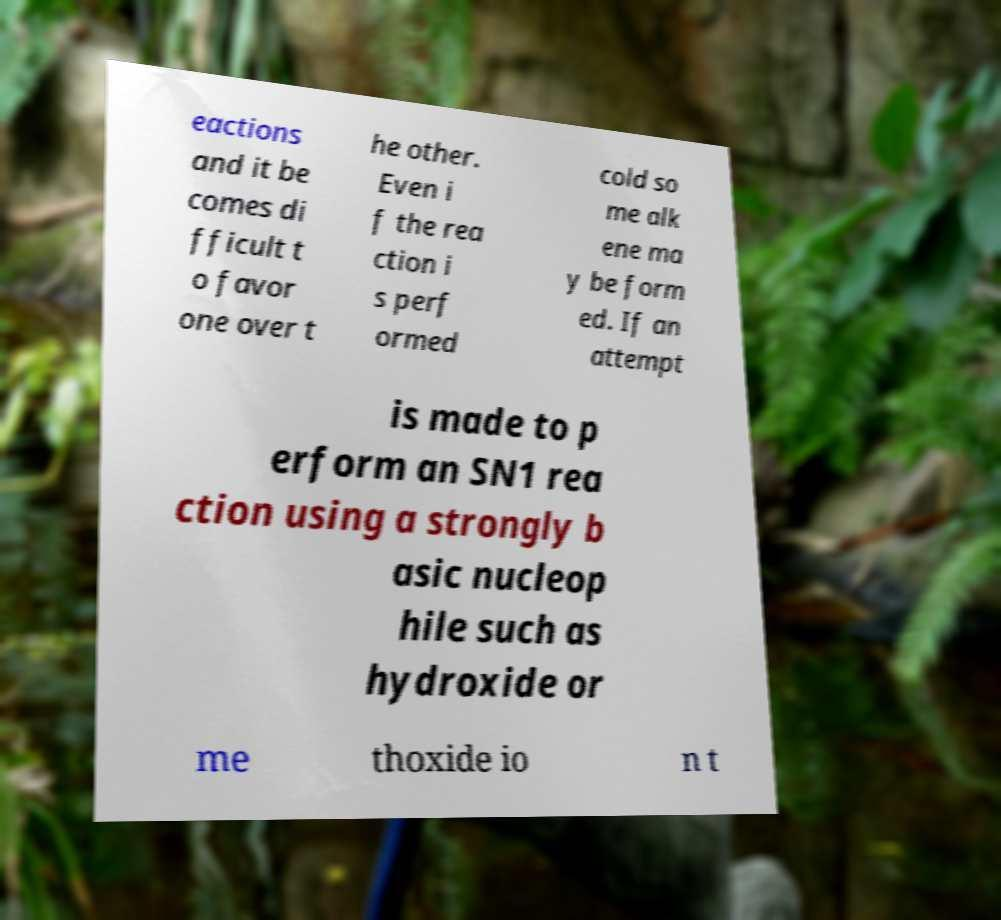Please read and relay the text visible in this image. What does it say? eactions and it be comes di fficult t o favor one over t he other. Even i f the rea ction i s perf ormed cold so me alk ene ma y be form ed. If an attempt is made to p erform an SN1 rea ction using a strongly b asic nucleop hile such as hydroxide or me thoxide io n t 